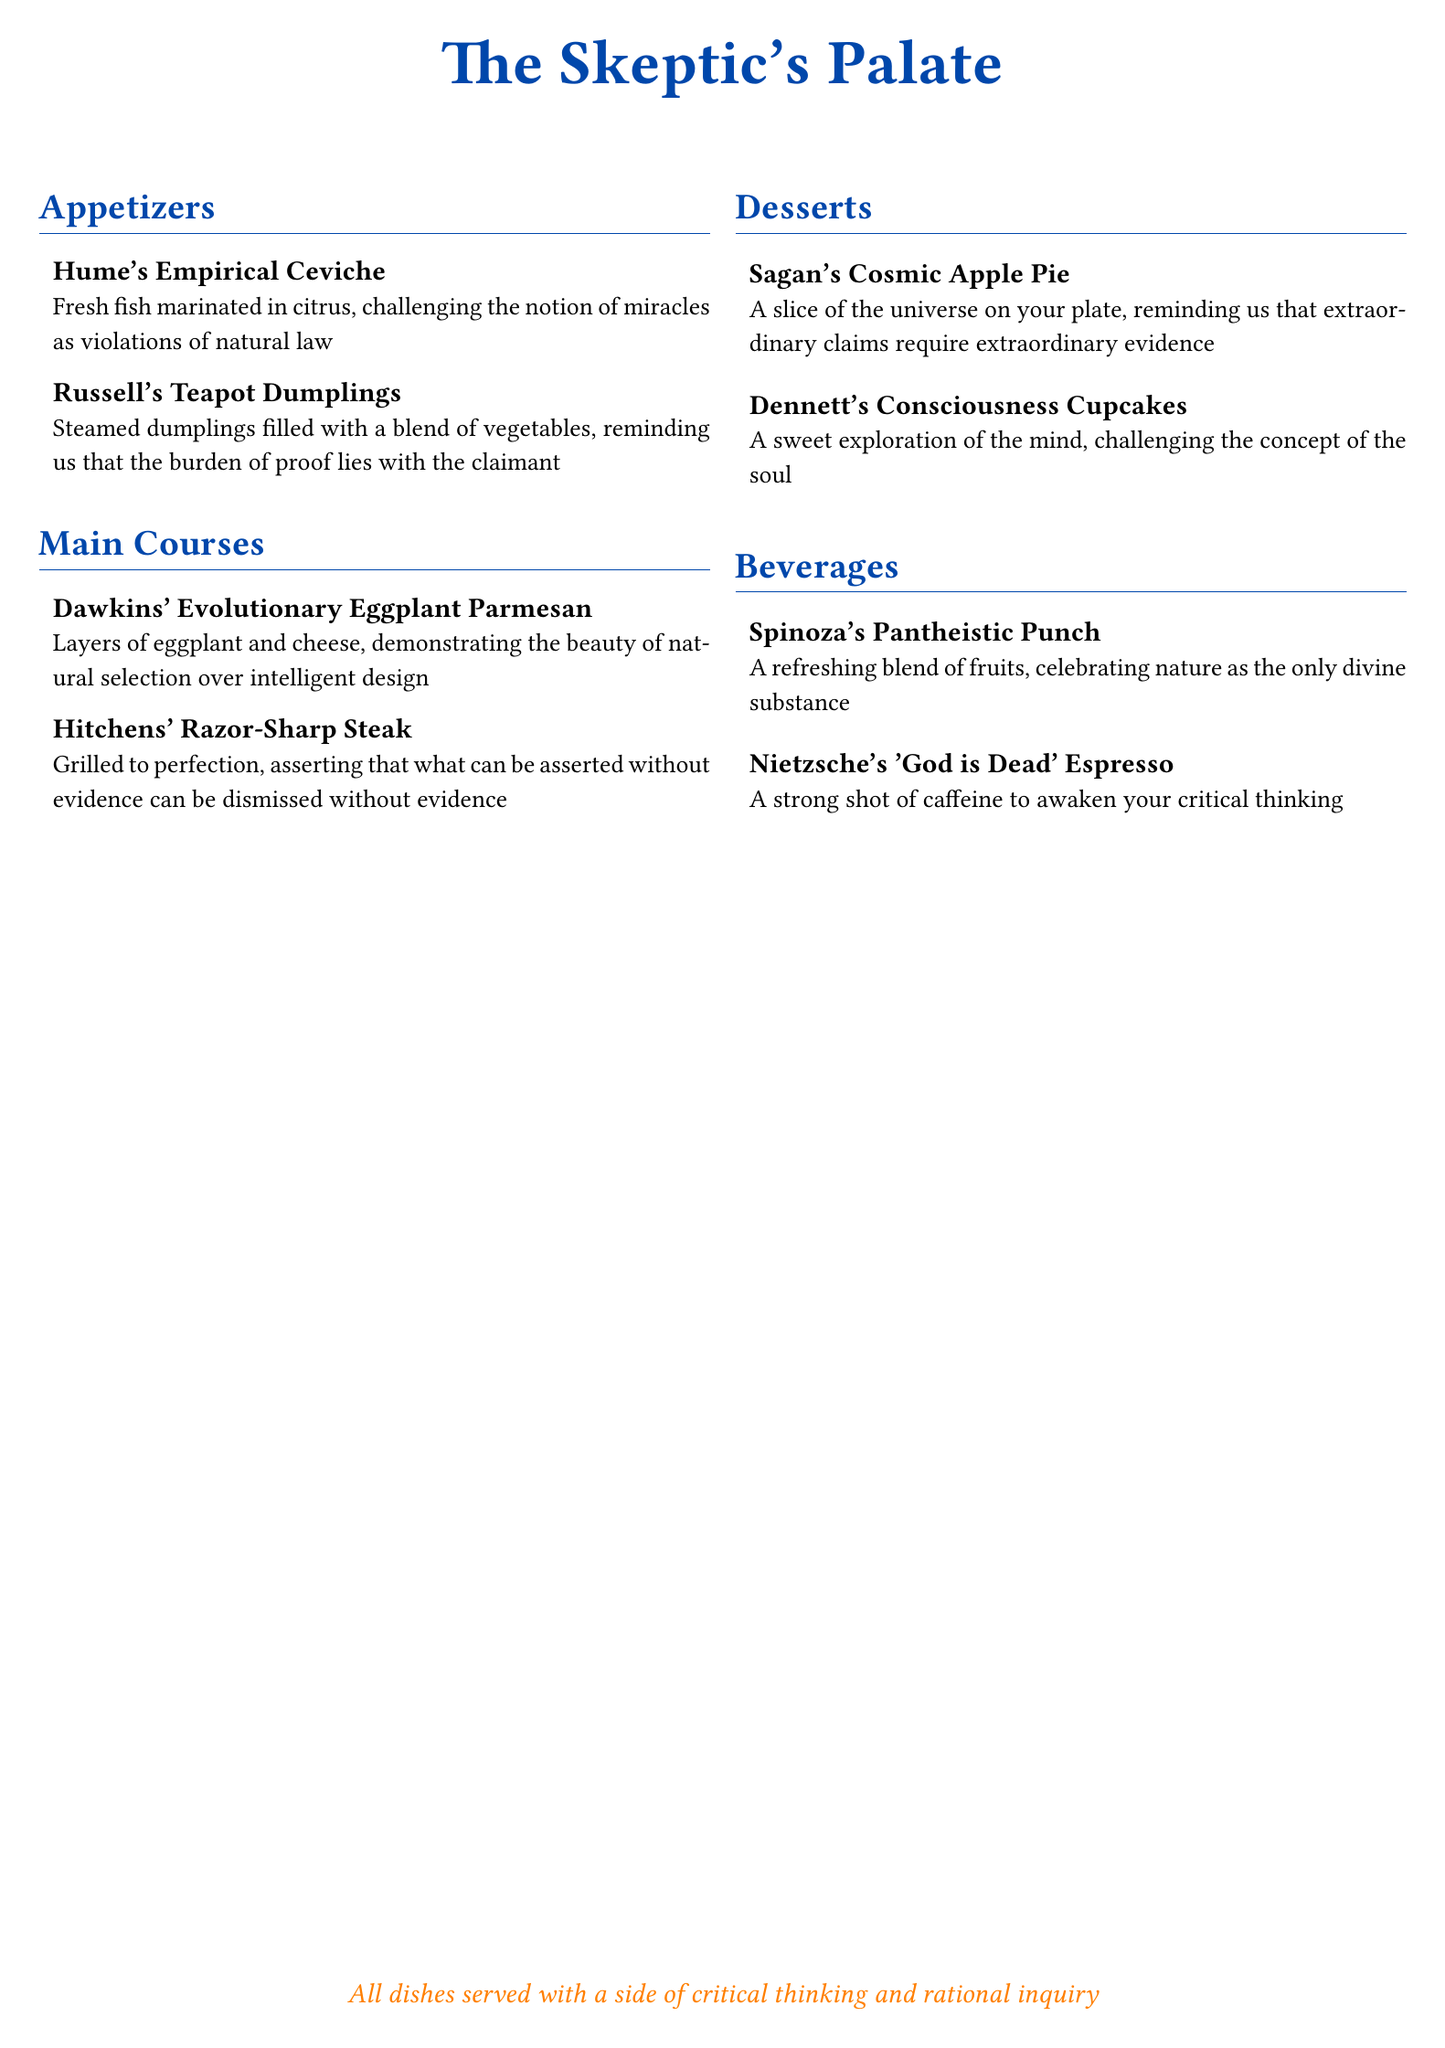What is the name of the appetizer that references the philosopher David Hume? The appetizer named after David Hume is "Hume's Empirical Ceviche."
Answer: Hume's Empirical Ceviche What dish is served as the main course that relates to Richard Dawkins? The main course related to Richard Dawkins is "Dawkins' Evolutionary Eggplant Parmesan."
Answer: Dawkins' Evolutionary Eggplant Parmesan What is the theme of the dessert section? The dessert section explores concepts related to consciousness and extraordinary claims.
Answer: Consciousness and extraordinary claims Which beverage is named after Baruch Spinoza? The beverage named after Baruch Spinoza is "Spinoza's Pantheistic Punch."
Answer: Spinoza's Pantheistic Punch How many appetizers are listed on the menu? There are two appetizers listed on the menu.
Answer: Two What philosophical idea is represented by Nietzsche's beverage? Nietzsche's beverage represents the idea that "God is Dead."
Answer: God is Dead Which dish challenges the notion of the soul? The dish that challenges the notion of the soul is "Dennett's Consciousness Cupcakes."
Answer: Dennett's Consciousness Cupcakes What is included with every dish? Every dish is served with a side of critical thinking and rational inquiry.
Answer: Critical thinking and rational inquiry 